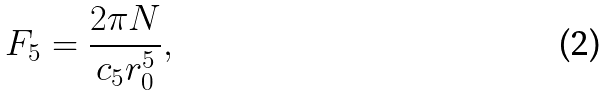<formula> <loc_0><loc_0><loc_500><loc_500>F _ { 5 } = \frac { 2 \pi N } { c _ { 5 } r _ { 0 } ^ { 5 } } ,</formula> 